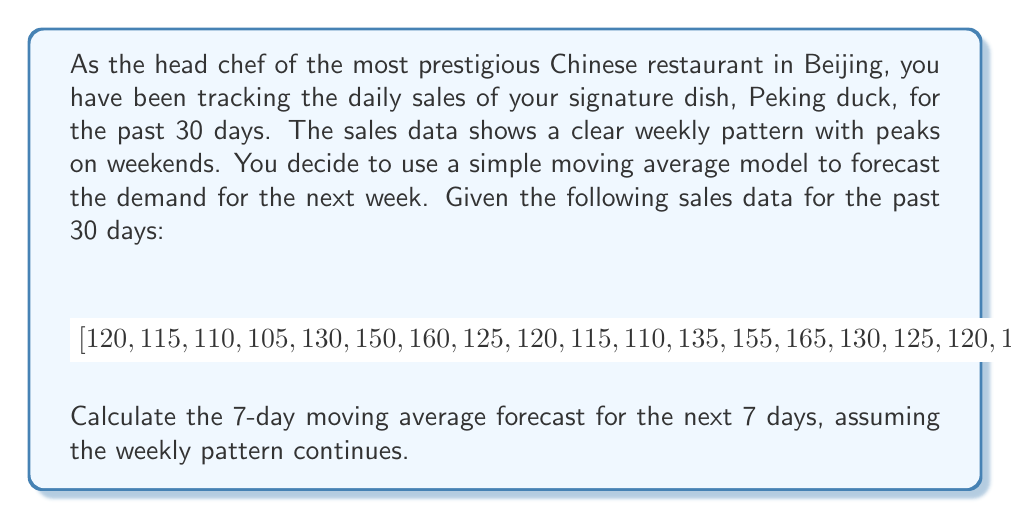What is the answer to this math problem? To solve this problem, we'll follow these steps:

1) First, we need to calculate the 7-day moving averages for the given data. The formula for a 7-day moving average is:

   $$MA_7(t) = \frac{1}{7} \sum_{i=t-6}^t x_i$$

   where $x_i$ is the sales value for day $i$.

2) We'll calculate this for the last 7 complete sets of 7 days in our data:

   Day 24-30: $\frac{120 + 145 + 165 + 175 + 140 + 135 + 135}{7} = 145$
   Day 23-29: $\frac{125 + 120 + 145 + 165 + 175 + 140 + 135}{7} \approx 143.57$
   Day 22-28: $\frac{130 + 125 + 120 + 145 + 165 + 175 + 140}{7} = 142.86$
   Day 21-27: $\frac{135 + 130 + 125 + 120 + 145 + 165 + 175}{7} = 142.14$
   Day 20-26: $\frac{170 + 135 + 130 + 125 + 120 + 145 + 165}{7} = 141.43$
   Day 19-25: $\frac{160 + 170 + 135 + 130 + 125 + 120 + 145}{7} \approx 140.71$
   Day 18-24: $\frac{140 + 160 + 170 + 135 + 130 + 125 + 120}{7} = 140$

3) Now, we need to use these 7 values to forecast the next 7 days. Since we observed a weekly pattern, we can assume that these 7 values will repeat in the same order for the next week.

4) Therefore, our forecast for the next 7 days would be:

   Day 31: 145
   Day 32: 143.57
   Day 33: 142.86
   Day 34: 142.14
   Day 35: 141.43
   Day 36: 140.71
   Day 37: 140

This simple moving average model assumes that the weekly pattern will continue and uses the average of the past week to predict each day of the coming week.
Answer: The 7-day moving average forecast for the next 7 days is:

$$[145, 143.57, 142.86, 142.14, 141.43, 140.71, 140]$$ 